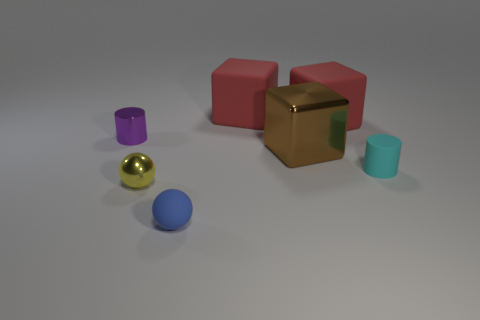There is a matte object that is the same size as the blue rubber ball; what is its color?
Keep it short and to the point. Cyan. What is the shape of the small yellow object that is left of the small rubber sphere that is in front of the large rubber object that is right of the brown metal object?
Provide a succinct answer. Sphere. How many small cylinders are in front of the cylinder behind the large metal thing?
Give a very brief answer. 1. There is a tiny object to the right of the small blue object; is it the same shape as the big brown thing behind the small matte ball?
Your answer should be compact. No. There is a small yellow ball; how many large matte things are right of it?
Make the answer very short. 2. Is the material of the tiny cylinder in front of the purple metallic object the same as the tiny purple cylinder?
Ensure brevity in your answer.  No. There is another thing that is the same shape as the blue object; what is its color?
Provide a succinct answer. Yellow. What is the shape of the cyan thing?
Provide a succinct answer. Cylinder. How many things are either large cyan rubber cylinders or big red rubber blocks?
Offer a very short reply. 2. Is the color of the small cylinder to the left of the cyan cylinder the same as the cylinder that is on the right side of the tiny purple metallic object?
Keep it short and to the point. No. 